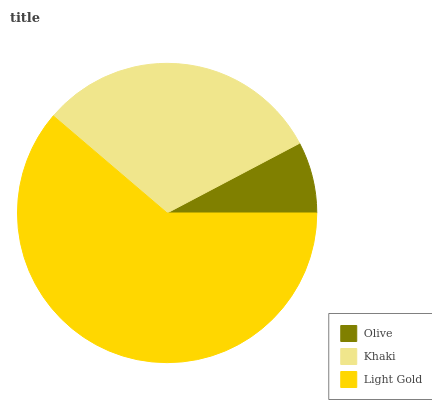Is Olive the minimum?
Answer yes or no. Yes. Is Light Gold the maximum?
Answer yes or no. Yes. Is Khaki the minimum?
Answer yes or no. No. Is Khaki the maximum?
Answer yes or no. No. Is Khaki greater than Olive?
Answer yes or no. Yes. Is Olive less than Khaki?
Answer yes or no. Yes. Is Olive greater than Khaki?
Answer yes or no. No. Is Khaki less than Olive?
Answer yes or no. No. Is Khaki the high median?
Answer yes or no. Yes. Is Khaki the low median?
Answer yes or no. Yes. Is Olive the high median?
Answer yes or no. No. Is Light Gold the low median?
Answer yes or no. No. 